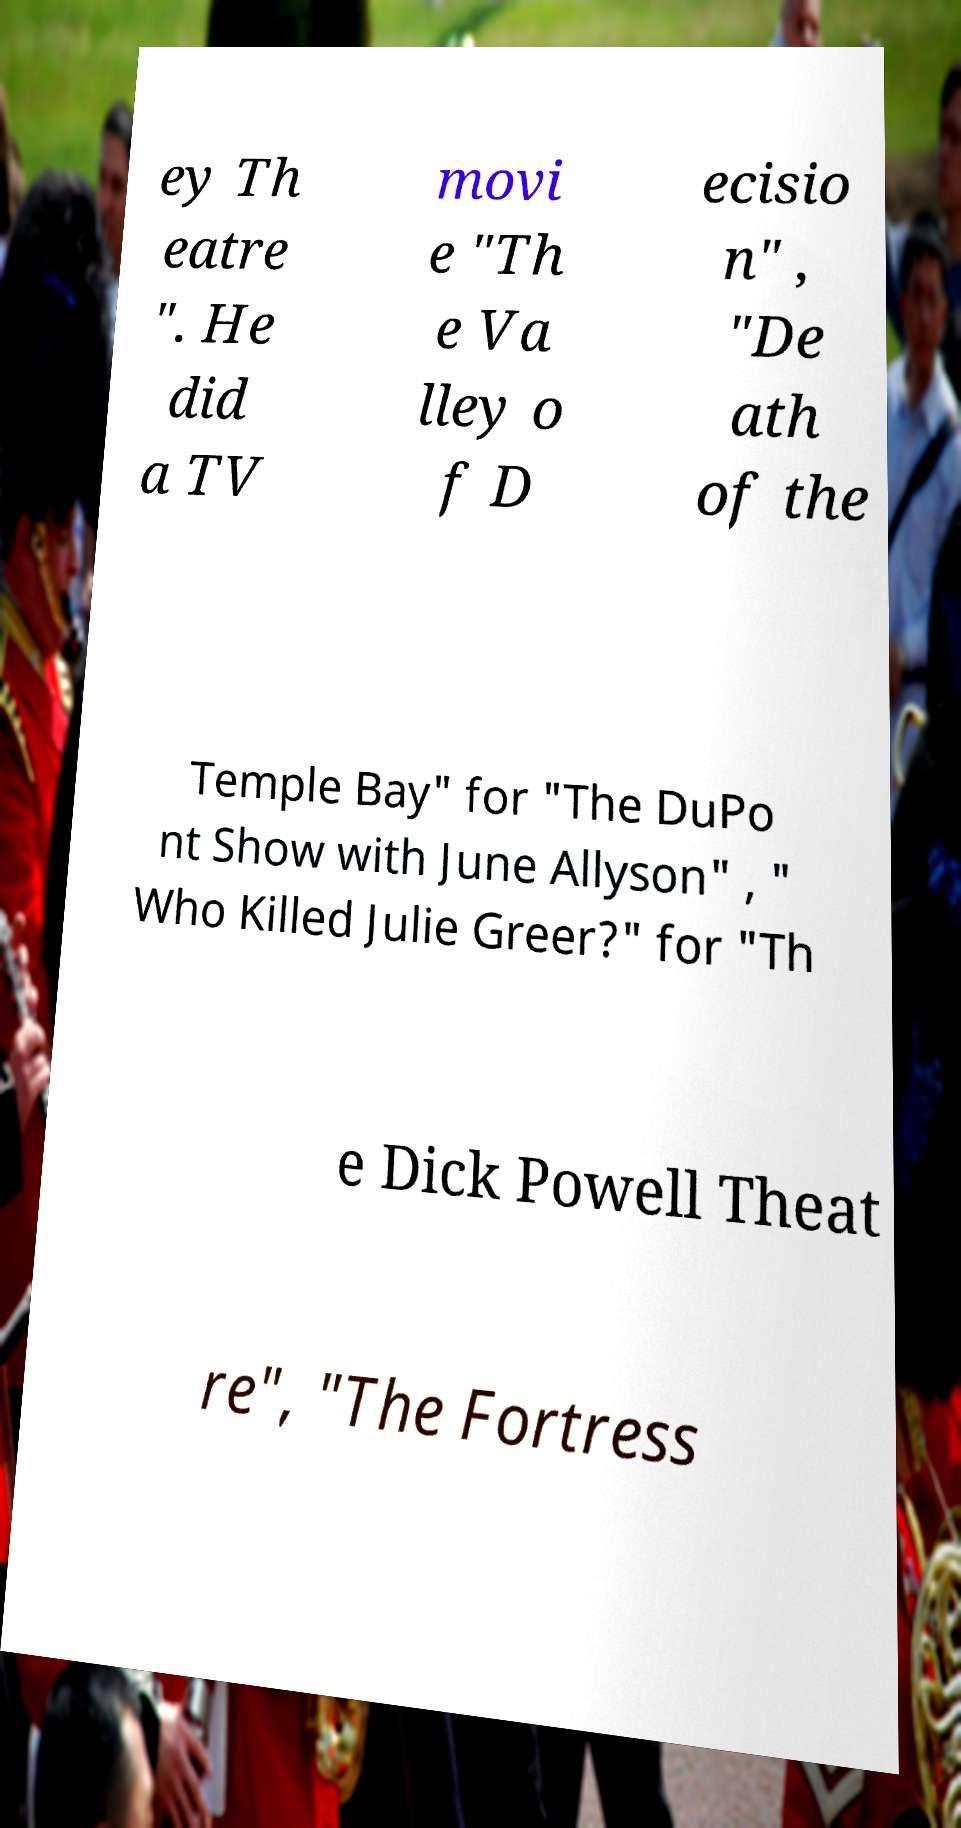Could you extract and type out the text from this image? ey Th eatre ". He did a TV movi e "Th e Va lley o f D ecisio n" , "De ath of the Temple Bay" for "The DuPo nt Show with June Allyson" , " Who Killed Julie Greer?" for "Th e Dick Powell Theat re", "The Fortress 